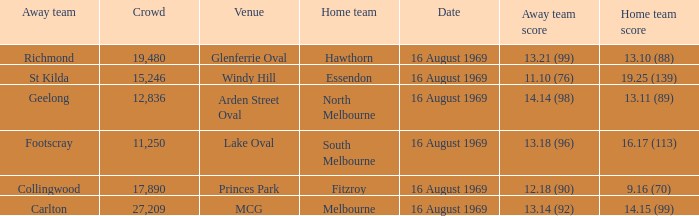When was the game played at Lake Oval? 16 August 1969. 